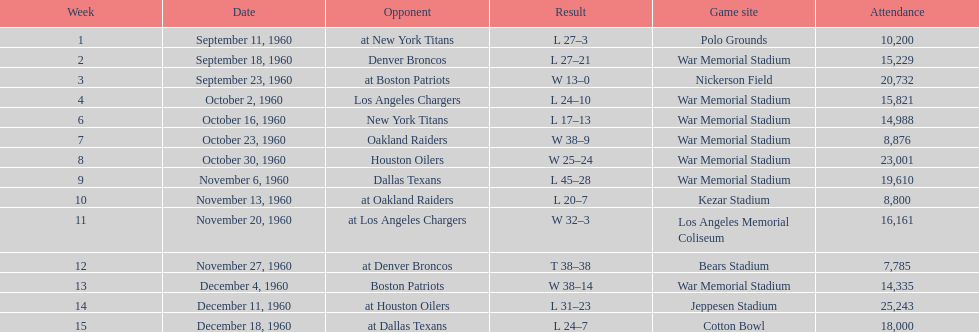In how many matches were there 10,000 or more attendees present? 11. 